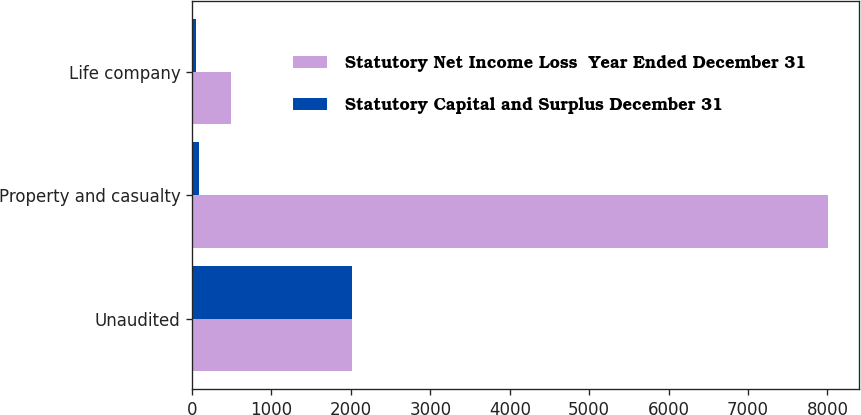Convert chart. <chart><loc_0><loc_0><loc_500><loc_500><stacked_bar_chart><ecel><fcel>Unaudited<fcel>Property and casualty<fcel>Life company<nl><fcel>Statutory Net Income Loss  Year Ended December 31<fcel>2008<fcel>8002<fcel>487<nl><fcel>Statutory Capital and Surplus December 31<fcel>2008<fcel>89<fcel>51<nl></chart> 